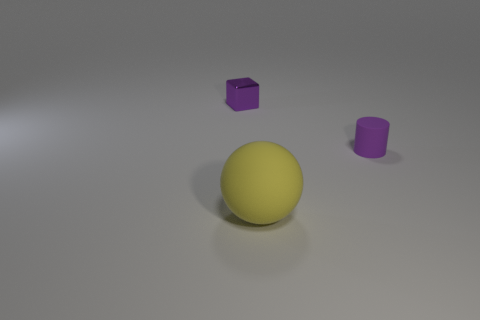Add 2 tiny brown cubes. How many objects exist? 5 Subtract all cubes. How many objects are left? 2 Subtract 1 spheres. How many spheres are left? 0 Subtract all gray balls. Subtract all blue cylinders. How many balls are left? 1 Subtract all metallic cylinders. Subtract all blocks. How many objects are left? 2 Add 2 large things. How many large things are left? 3 Add 2 yellow balls. How many yellow balls exist? 3 Subtract 0 brown cylinders. How many objects are left? 3 